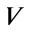<formula> <loc_0><loc_0><loc_500><loc_500>V</formula> 